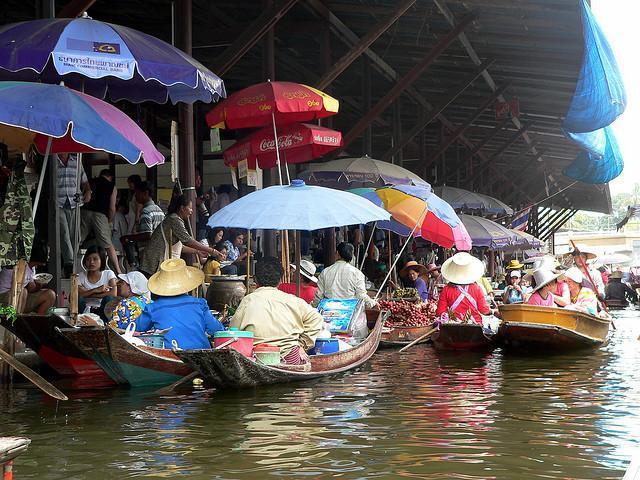How many umbrellas are in this picture?
Give a very brief answer. 9. How many umbrellas are visible?
Give a very brief answer. 7. How many people are in the photo?
Give a very brief answer. 5. How many boats are in the photo?
Give a very brief answer. 4. 